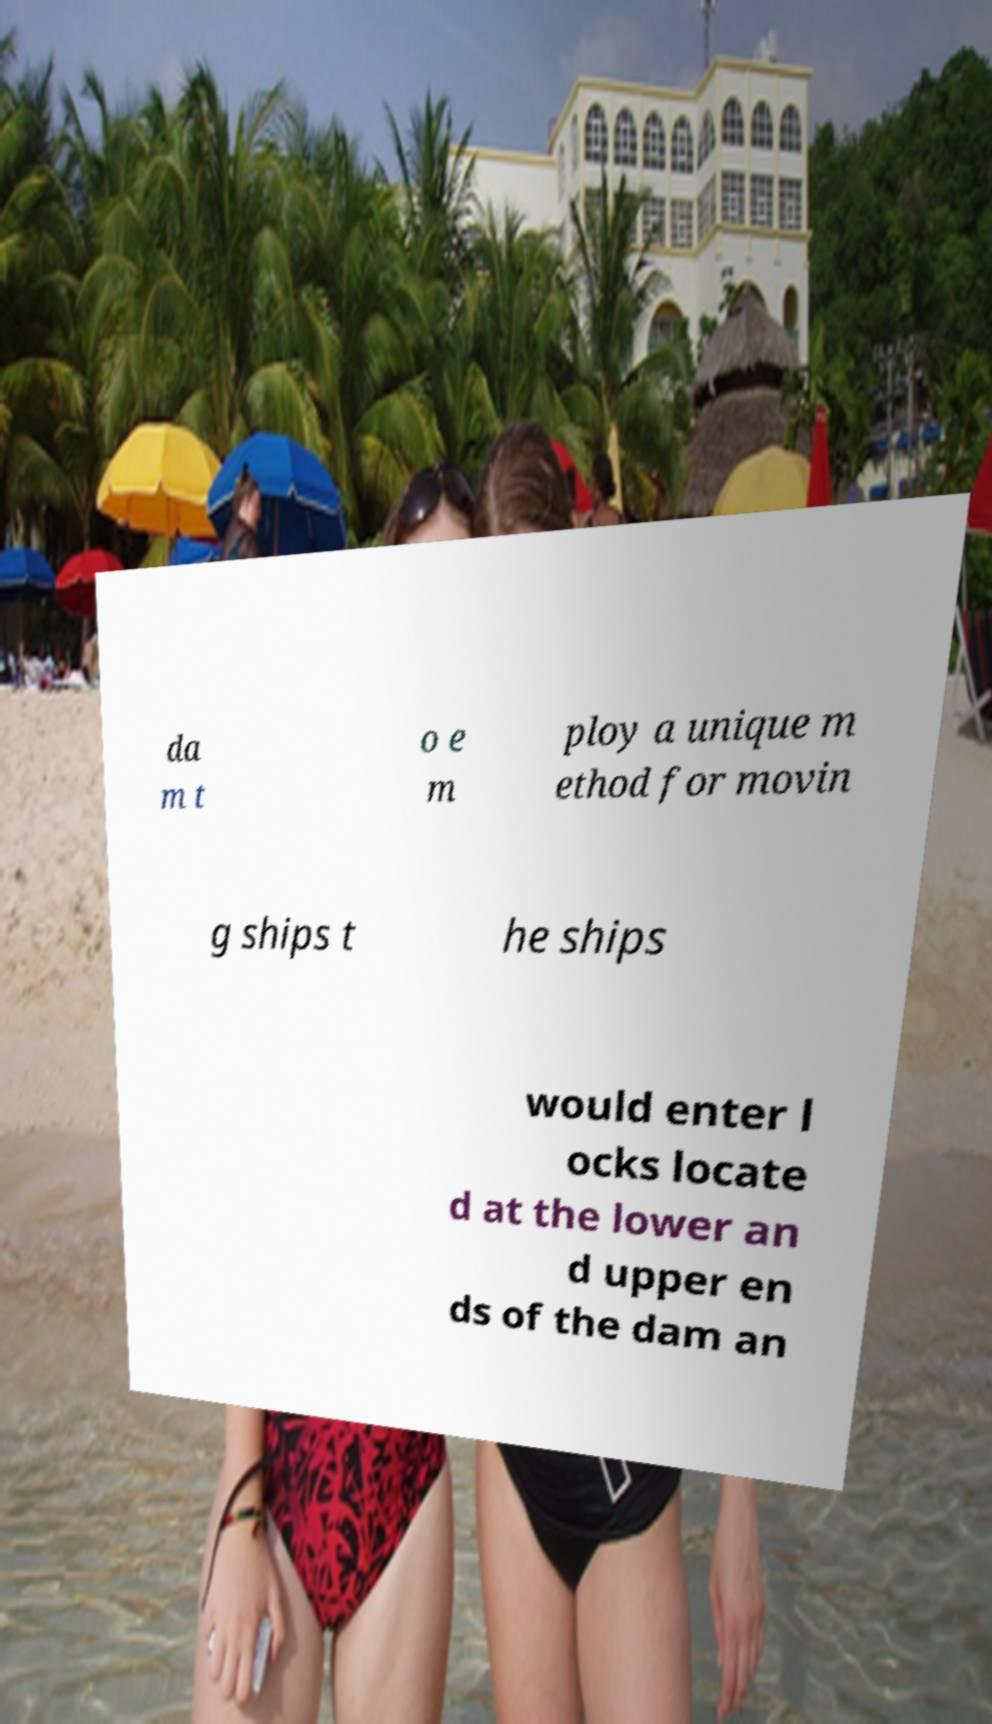Could you extract and type out the text from this image? da m t o e m ploy a unique m ethod for movin g ships t he ships would enter l ocks locate d at the lower an d upper en ds of the dam an 